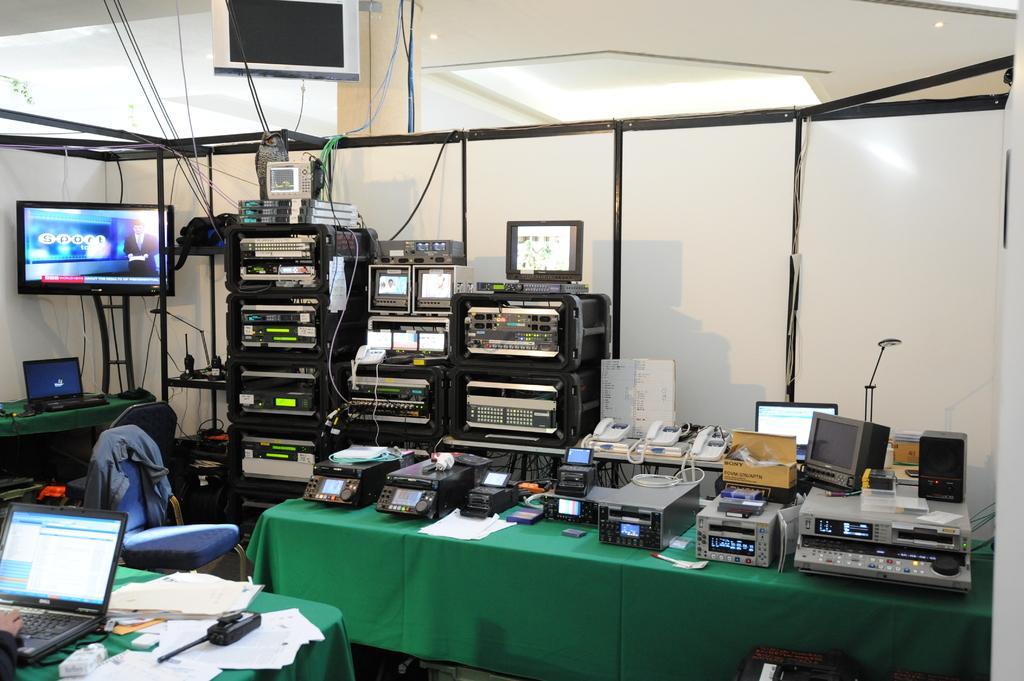In one or two sentences, can you explain what this image depicts? In this image there is a table in the center, on the table there are some machines and in the background also there are some machines and some screens, telephones, computers, boxes, wires and objects. And on the left side of the image there is table, and on the table there are some papers, phone and laptop and one person is typing it seems and there is a chair. On the chair there is cloth, and in the background there is a television, laptop, table and some machines, wires and at the top also there is one television and in the center there are some boards. At the top there is ceiling and in the center there is a pillar and some wires and also we could see lights. 